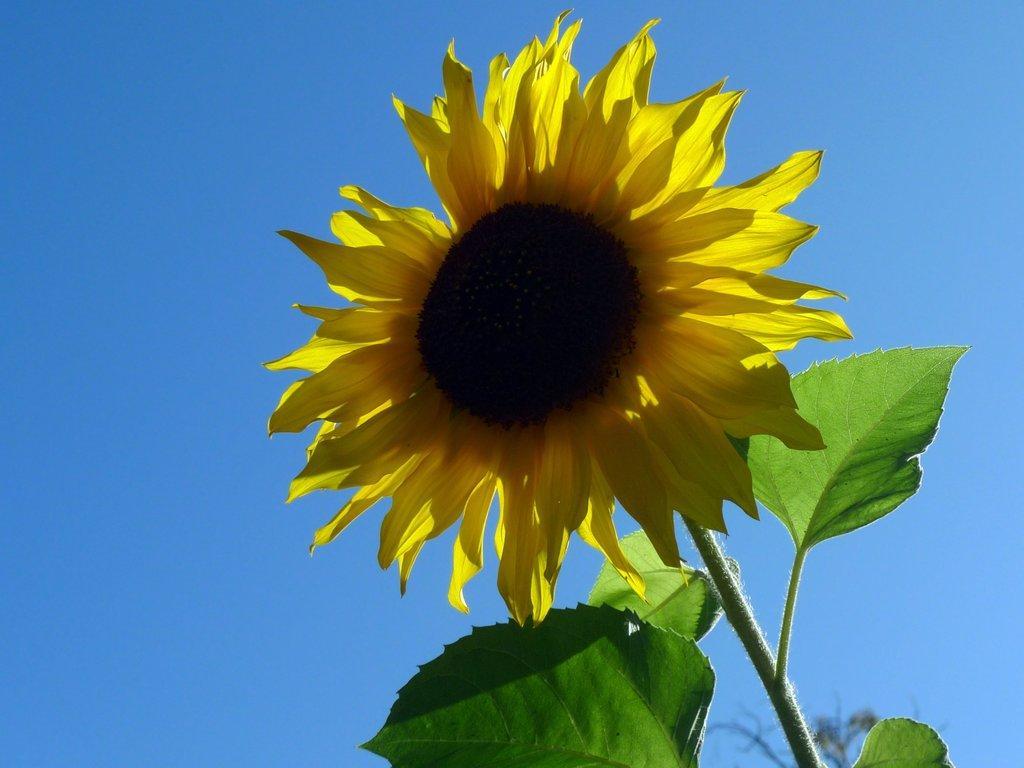Can you describe this image briefly? In this picture I can see a sunflower with leaves, and in the background there is the sky. 